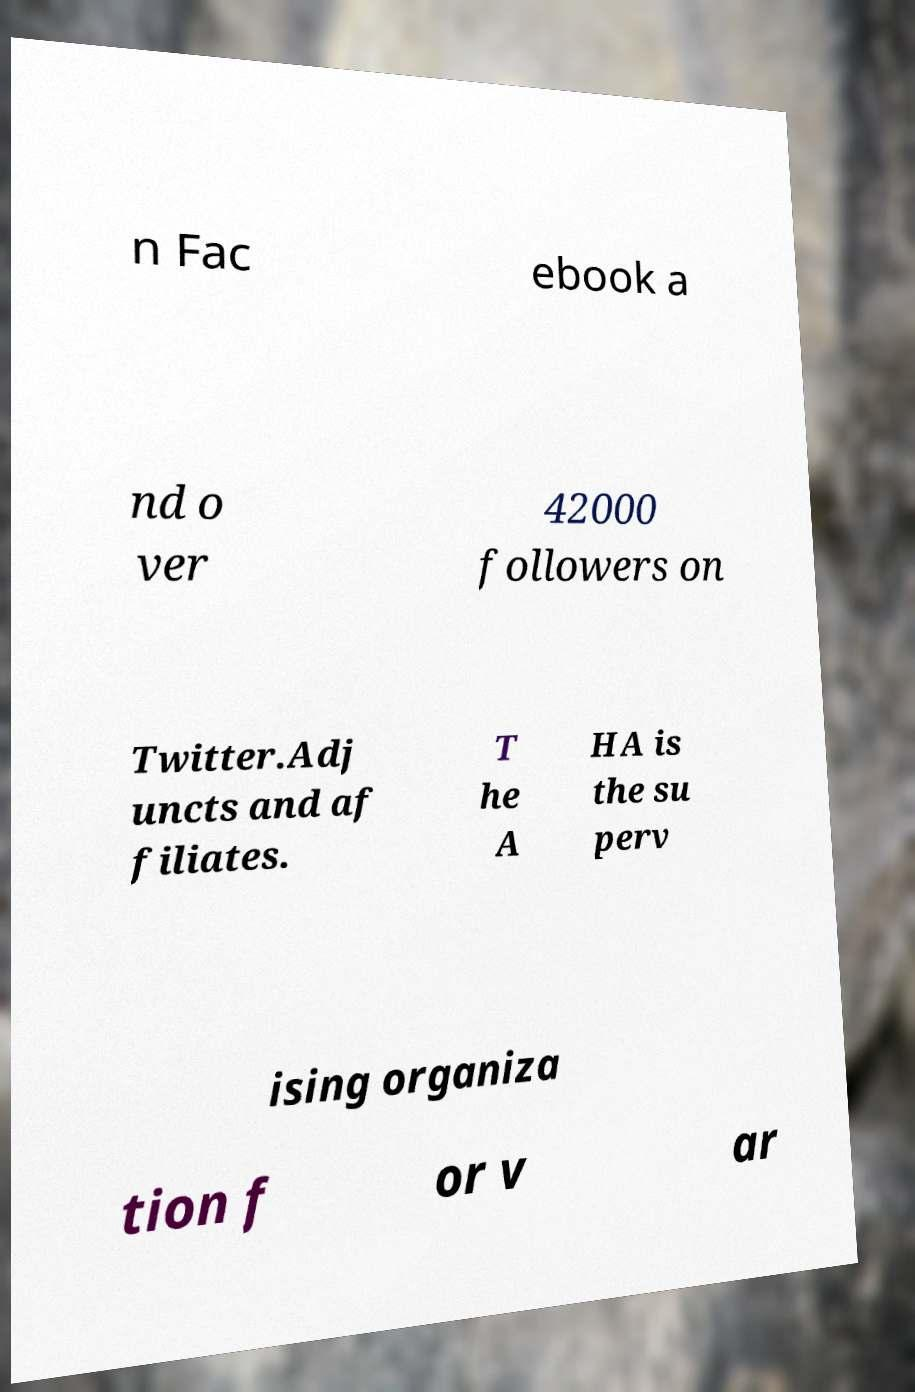There's text embedded in this image that I need extracted. Can you transcribe it verbatim? n Fac ebook a nd o ver 42000 followers on Twitter.Adj uncts and af filiates. T he A HA is the su perv ising organiza tion f or v ar 